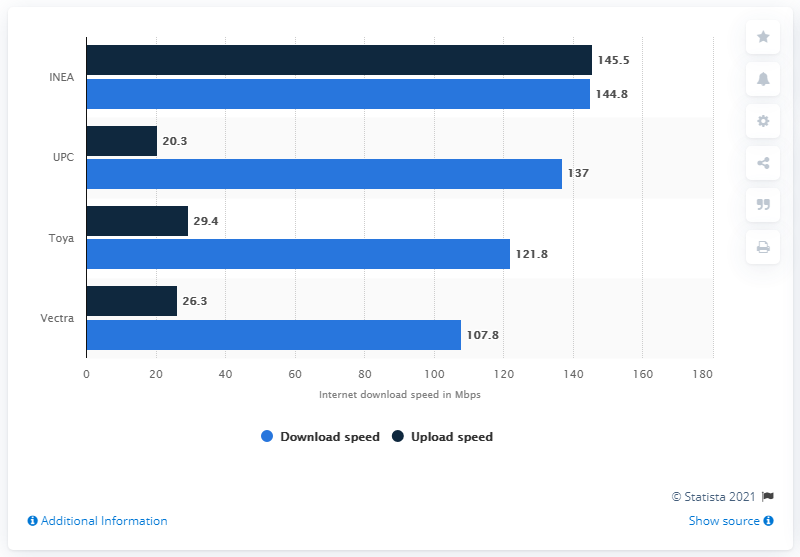Indicate a few pertinent items in this graphic. In 2020, UPC was the second fastest internet service provider in Poland. 